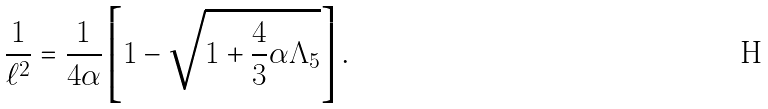<formula> <loc_0><loc_0><loc_500><loc_500>\frac { 1 } { \ell ^ { 2 } } = \frac { 1 } { 4 \alpha } \left [ 1 - \sqrt { 1 + \frac { 4 } { 3 } \alpha \Lambda _ { 5 } } \right ] .</formula> 